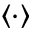Convert formula to latex. <formula><loc_0><loc_0><loc_500><loc_500>\langle \cdot \rangle</formula> 